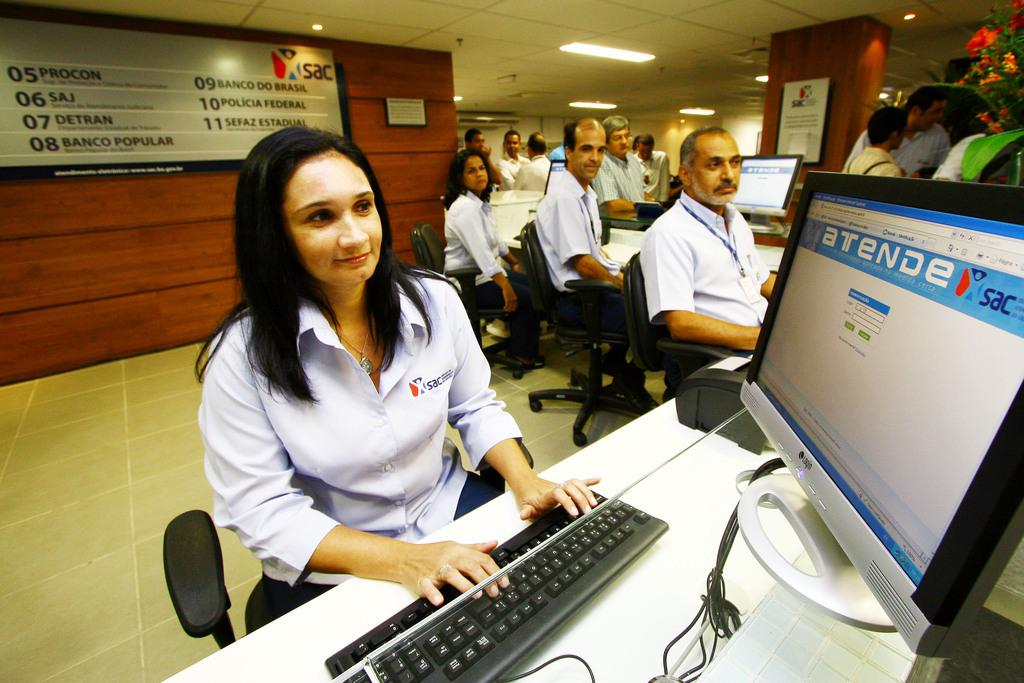Provide a one-sentence caption for the provided image. A woman who for works at SAC is working on her computer in an office with colleagues. 